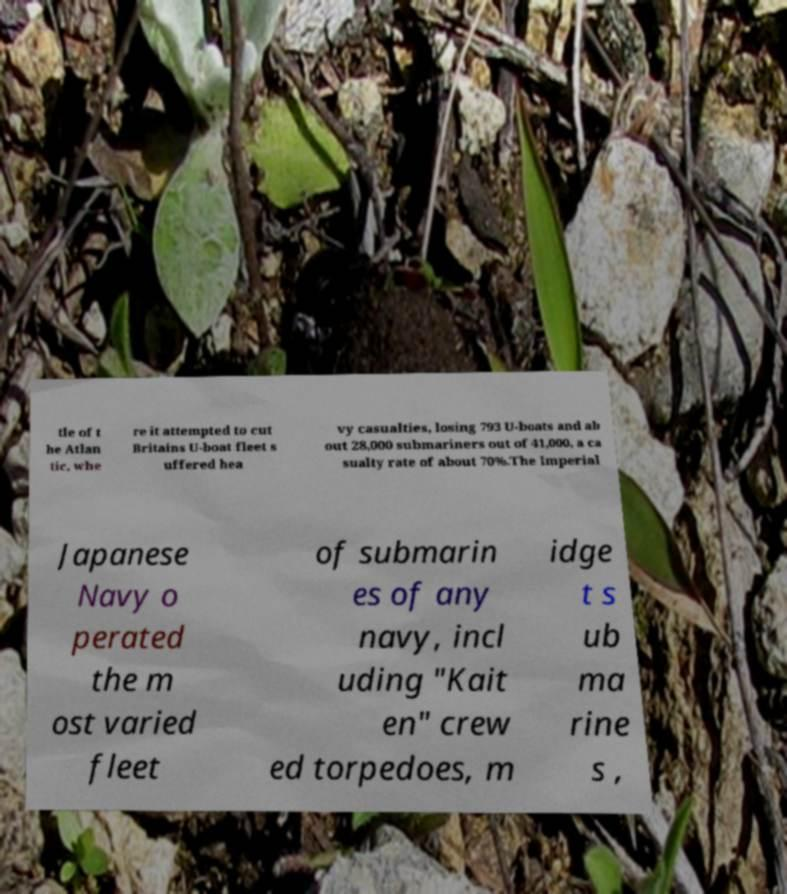What messages or text are displayed in this image? I need them in a readable, typed format. tle of t he Atlan tic, whe re it attempted to cut Britains U-boat fleet s uffered hea vy casualties, losing 793 U-boats and ab out 28,000 submariners out of 41,000, a ca sualty rate of about 70%.The Imperial Japanese Navy o perated the m ost varied fleet of submarin es of any navy, incl uding "Kait en" crew ed torpedoes, m idge t s ub ma rine s , 